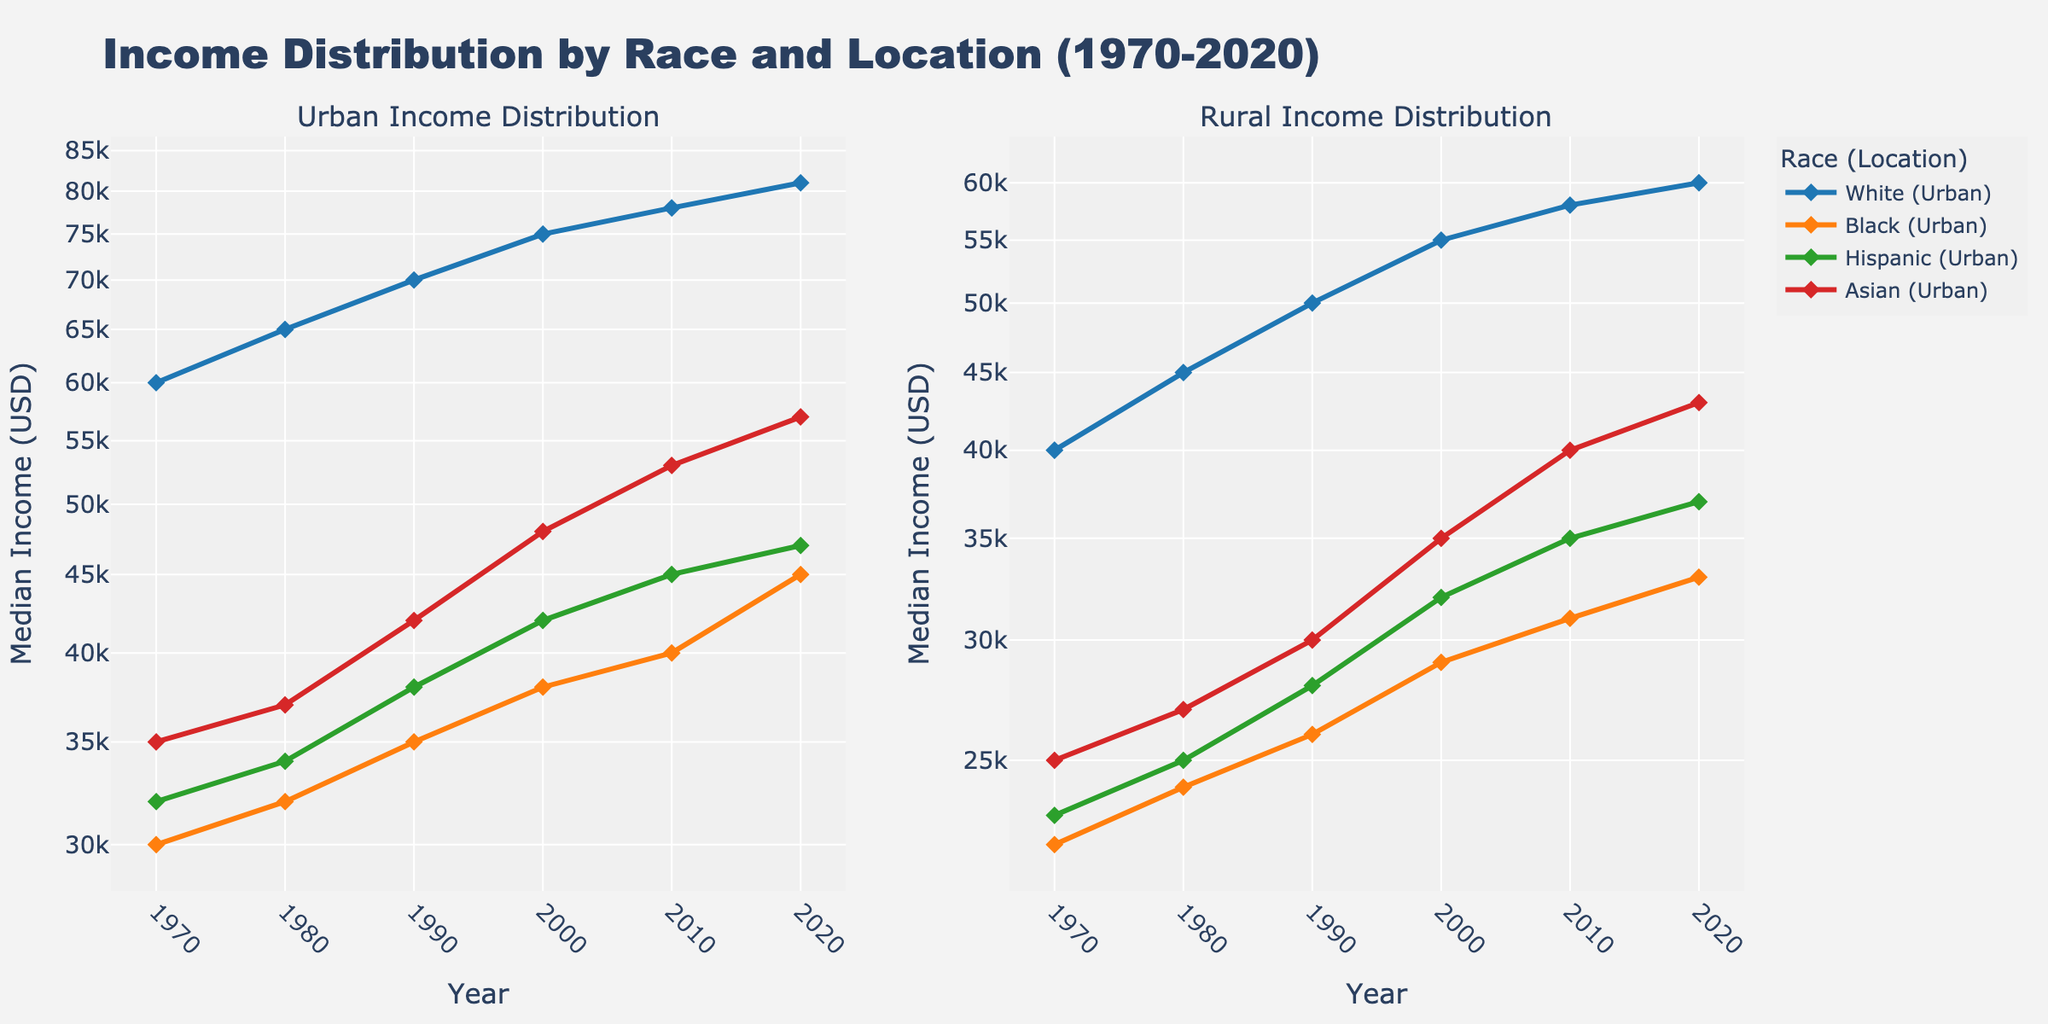What is the title of the figure? The title is typically displayed at the top of the plot. In this case, it shows "Income Distribution by Race and Location (1970-2020)."
Answer: Income Distribution by Race and Location (1970-2020) Which location has a higher median income for Whites in 2020? Look at the two subplots and compare the 2020 data point for Whites in both Urban and Rural contexts. On the Urban subplot, Whites have a median income of 81,000 USD, while on the Rural subplot, it's 60,000 USD.
Answer: Urban Which racial group shows the most significant increase in median income in Urban areas from 1970 to 2020? For each race in the Urban subplot, calculate the difference in median income from 1970 to 2020: White (81,000 - 60,000), Black (45,000 - 30,000), Hispanic (47,000 - 32,000), Asian (57,000 - 35,000). The group with the highest difference is the one with the most significant increase.
Answer: White How does the median income of Asians in rural areas in 1970 compare to their median income in 2020? Locate the data points for Asians in the Rural subplot for 1970 and 2020. In 1970, the median income is 25,000 USD, and in 2020, it is 43,000 USD. Compare these two values: 43,000 is much higher than 25,000.
Answer: Increased significantly What is the median income of Hispanics in Urban areas in 1990? Locate the data points for Hispanics in the Urban subplot for the year 1990, which shows a value of 38,000 USD.
Answer: 38,000 USD Which racial group in rural areas had the lowest median income in 1980? Check the data points for each racial group in rural areas for 1980. Black (24,000 USD), Hispanic (25,000 USD), Asian (27,000 USD), White (45,000 USD). The lowest value is for Blacks.
Answer: Black What is the difference in median income between Black and Hispanic populations in Urban areas in 2020? Find the data points for both Black and Hispanic populations in Urban areas for the year 2020 and subtract them: 45,000 USD (Black) - 47,000 USD (Hispanic).
Answer: -2,000 USD On a logarithmic scale, which group in Rural areas had the highest median income in 2010? On the Rural subplot, identify the highest data point for the year 2010, which is for Whites with a median income of 58,000 USD.
Answer: White What trend can you observe for median income of the Black population in Urban areas over the 50 years? Observe the line for the Black population in Urban areas. The trend shows a gradual increase from 30,000 USD in 1970 to 45,000 USD in 2020.
Answer: Gradual increase How does the median income gap between Urban and Rural areas for the White population change from 2000 to 2010? Calculate the difference for Whites between Urban and Rural areas for 2000 and 2010. In 2000: 75,000 - 55,000 = 20,000 USD; in 2010: 78,000 - 58,000 = 20,000 USD. The gap remains the same.
Answer: Remains the same 